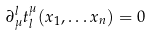Convert formula to latex. <formula><loc_0><loc_0><loc_500><loc_500>\partial _ { \mu } ^ { l } t _ { l } ^ { \mu } ( x _ { 1 } , \dots x _ { n } ) = 0 \quad</formula> 